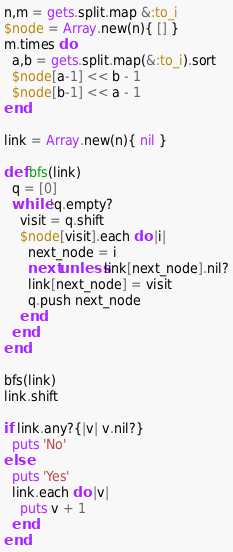Convert code to text. <code><loc_0><loc_0><loc_500><loc_500><_Ruby_>n,m = gets.split.map &:to_i
$node = Array.new(n){ [] }
m.times do
  a,b = gets.split.map(&:to_i).sort
  $node[a-1] << b - 1
  $node[b-1] << a - 1
end

link = Array.new(n){ nil }

def bfs(link)
  q = [0]
  while !q.empty?
    visit = q.shift
    $node[visit].each do |i|
      next_node = i 
      next unless link[next_node].nil?
      link[next_node] = visit
      q.push next_node 
    end
  end
end

bfs(link)
link.shift

if link.any?{|v| v.nil?}
  puts 'No'
else
  puts 'Yes'
  link.each do |v|
    puts v + 1
  end
end


</code> 